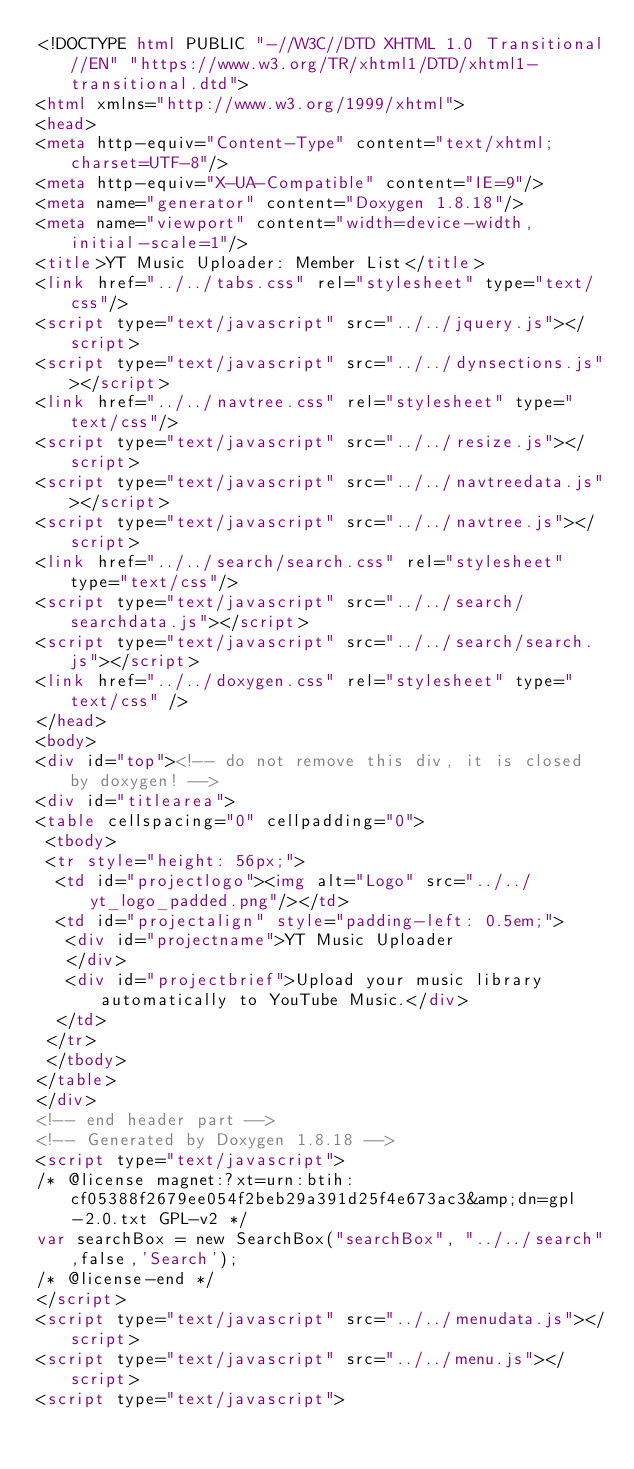<code> <loc_0><loc_0><loc_500><loc_500><_HTML_><!DOCTYPE html PUBLIC "-//W3C//DTD XHTML 1.0 Transitional//EN" "https://www.w3.org/TR/xhtml1/DTD/xhtml1-transitional.dtd">
<html xmlns="http://www.w3.org/1999/xhtml">
<head>
<meta http-equiv="Content-Type" content="text/xhtml;charset=UTF-8"/>
<meta http-equiv="X-UA-Compatible" content="IE=9"/>
<meta name="generator" content="Doxygen 1.8.18"/>
<meta name="viewport" content="width=device-width, initial-scale=1"/>
<title>YT Music Uploader: Member List</title>
<link href="../../tabs.css" rel="stylesheet" type="text/css"/>
<script type="text/javascript" src="../../jquery.js"></script>
<script type="text/javascript" src="../../dynsections.js"></script>
<link href="../../navtree.css" rel="stylesheet" type="text/css"/>
<script type="text/javascript" src="../../resize.js"></script>
<script type="text/javascript" src="../../navtreedata.js"></script>
<script type="text/javascript" src="../../navtree.js"></script>
<link href="../../search/search.css" rel="stylesheet" type="text/css"/>
<script type="text/javascript" src="../../search/searchdata.js"></script>
<script type="text/javascript" src="../../search/search.js"></script>
<link href="../../doxygen.css" rel="stylesheet" type="text/css" />
</head>
<body>
<div id="top"><!-- do not remove this div, it is closed by doxygen! -->
<div id="titlearea">
<table cellspacing="0" cellpadding="0">
 <tbody>
 <tr style="height: 56px;">
  <td id="projectlogo"><img alt="Logo" src="../../yt_logo_padded.png"/></td>
  <td id="projectalign" style="padding-left: 0.5em;">
   <div id="projectname">YT Music Uploader
   </div>
   <div id="projectbrief">Upload your music library automatically to YouTube Music.</div>
  </td>
 </tr>
 </tbody>
</table>
</div>
<!-- end header part -->
<!-- Generated by Doxygen 1.8.18 -->
<script type="text/javascript">
/* @license magnet:?xt=urn:btih:cf05388f2679ee054f2beb29a391d25f4e673ac3&amp;dn=gpl-2.0.txt GPL-v2 */
var searchBox = new SearchBox("searchBox", "../../search",false,'Search');
/* @license-end */
</script>
<script type="text/javascript" src="../../menudata.js"></script>
<script type="text/javascript" src="../../menu.js"></script>
<script type="text/javascript"></code> 